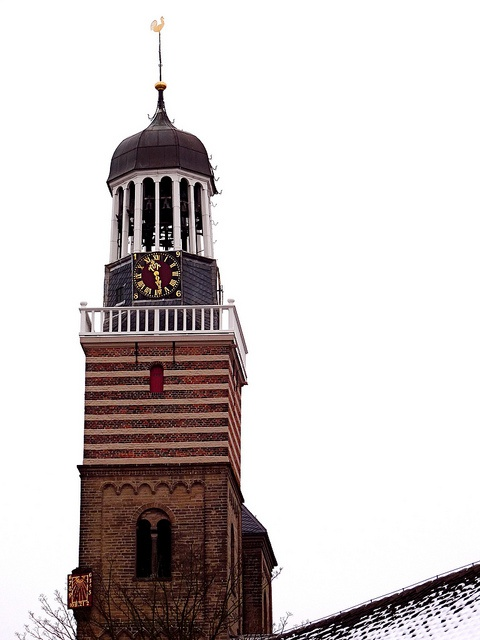Describe the objects in this image and their specific colors. I can see a clock in white, black, maroon, gray, and tan tones in this image. 